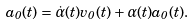<formula> <loc_0><loc_0><loc_500><loc_500>a _ { 0 } ( t ) = \dot { \alpha } ( t ) v _ { 0 } ( t ) + \alpha ( t ) a _ { 0 } ( t ) .</formula> 